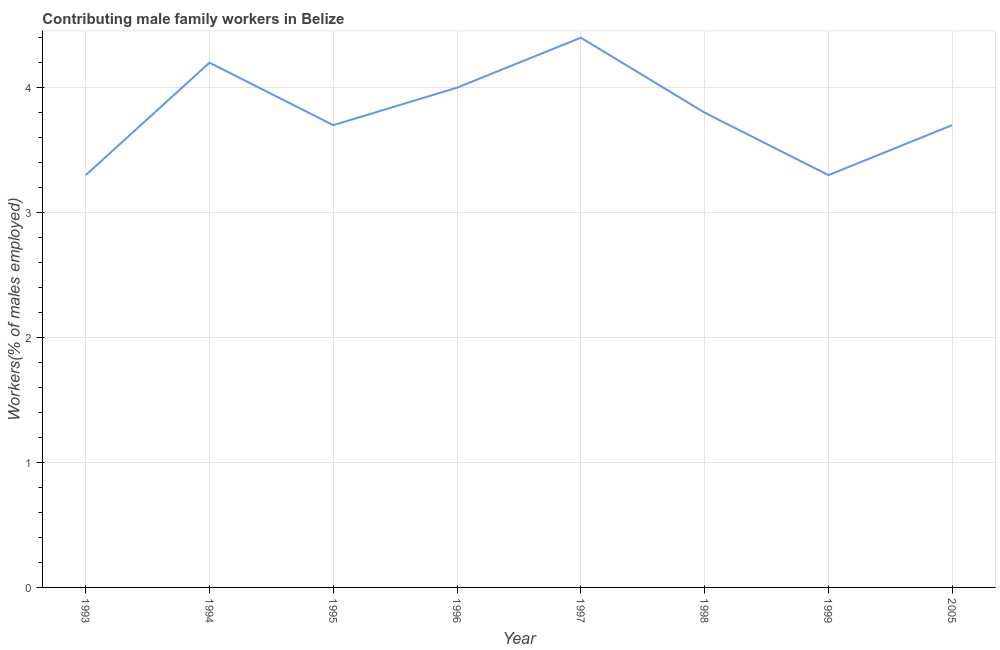What is the contributing male family workers in 2005?
Provide a short and direct response. 3.7. Across all years, what is the maximum contributing male family workers?
Offer a very short reply. 4.4. Across all years, what is the minimum contributing male family workers?
Provide a succinct answer. 3.3. In which year was the contributing male family workers maximum?
Make the answer very short. 1997. In which year was the contributing male family workers minimum?
Give a very brief answer. 1993. What is the sum of the contributing male family workers?
Provide a short and direct response. 30.4. What is the difference between the contributing male family workers in 1997 and 2005?
Offer a terse response. 0.7. What is the average contributing male family workers per year?
Your answer should be compact. 3.8. What is the median contributing male family workers?
Your answer should be very brief. 3.75. Do a majority of the years between 1996 and 1997 (inclusive) have contributing male family workers greater than 2.4 %?
Provide a succinct answer. Yes. What is the difference between the highest and the second highest contributing male family workers?
Give a very brief answer. 0.2. Is the sum of the contributing male family workers in 1993 and 2005 greater than the maximum contributing male family workers across all years?
Offer a very short reply. Yes. What is the difference between the highest and the lowest contributing male family workers?
Provide a succinct answer. 1.1. How many lines are there?
Keep it short and to the point. 1. How many years are there in the graph?
Your answer should be very brief. 8. Are the values on the major ticks of Y-axis written in scientific E-notation?
Provide a succinct answer. No. Does the graph contain grids?
Make the answer very short. Yes. What is the title of the graph?
Give a very brief answer. Contributing male family workers in Belize. What is the label or title of the Y-axis?
Your answer should be compact. Workers(% of males employed). What is the Workers(% of males employed) in 1993?
Ensure brevity in your answer.  3.3. What is the Workers(% of males employed) of 1994?
Offer a very short reply. 4.2. What is the Workers(% of males employed) of 1995?
Keep it short and to the point. 3.7. What is the Workers(% of males employed) of 1997?
Your answer should be very brief. 4.4. What is the Workers(% of males employed) in 1998?
Offer a very short reply. 3.8. What is the Workers(% of males employed) in 1999?
Provide a short and direct response. 3.3. What is the Workers(% of males employed) in 2005?
Provide a short and direct response. 3.7. What is the difference between the Workers(% of males employed) in 1993 and 1994?
Provide a short and direct response. -0.9. What is the difference between the Workers(% of males employed) in 1993 and 1995?
Provide a short and direct response. -0.4. What is the difference between the Workers(% of males employed) in 1993 and 1998?
Keep it short and to the point. -0.5. What is the difference between the Workers(% of males employed) in 1993 and 1999?
Provide a short and direct response. 0. What is the difference between the Workers(% of males employed) in 1994 and 1996?
Your response must be concise. 0.2. What is the difference between the Workers(% of males employed) in 1994 and 2005?
Your answer should be compact. 0.5. What is the difference between the Workers(% of males employed) in 1995 and 1998?
Your answer should be very brief. -0.1. What is the difference between the Workers(% of males employed) in 1995 and 2005?
Ensure brevity in your answer.  0. What is the difference between the Workers(% of males employed) in 1996 and 1997?
Give a very brief answer. -0.4. What is the difference between the Workers(% of males employed) in 1996 and 1998?
Make the answer very short. 0.2. What is the difference between the Workers(% of males employed) in 1996 and 1999?
Keep it short and to the point. 0.7. What is the difference between the Workers(% of males employed) in 1997 and 2005?
Make the answer very short. 0.7. What is the difference between the Workers(% of males employed) in 1998 and 1999?
Make the answer very short. 0.5. What is the difference between the Workers(% of males employed) in 1998 and 2005?
Make the answer very short. 0.1. What is the ratio of the Workers(% of males employed) in 1993 to that in 1994?
Your answer should be very brief. 0.79. What is the ratio of the Workers(% of males employed) in 1993 to that in 1995?
Provide a short and direct response. 0.89. What is the ratio of the Workers(% of males employed) in 1993 to that in 1996?
Ensure brevity in your answer.  0.82. What is the ratio of the Workers(% of males employed) in 1993 to that in 1998?
Your answer should be compact. 0.87. What is the ratio of the Workers(% of males employed) in 1993 to that in 1999?
Provide a succinct answer. 1. What is the ratio of the Workers(% of males employed) in 1993 to that in 2005?
Your answer should be very brief. 0.89. What is the ratio of the Workers(% of males employed) in 1994 to that in 1995?
Give a very brief answer. 1.14. What is the ratio of the Workers(% of males employed) in 1994 to that in 1997?
Your response must be concise. 0.95. What is the ratio of the Workers(% of males employed) in 1994 to that in 1998?
Your response must be concise. 1.1. What is the ratio of the Workers(% of males employed) in 1994 to that in 1999?
Make the answer very short. 1.27. What is the ratio of the Workers(% of males employed) in 1994 to that in 2005?
Your answer should be very brief. 1.14. What is the ratio of the Workers(% of males employed) in 1995 to that in 1996?
Keep it short and to the point. 0.93. What is the ratio of the Workers(% of males employed) in 1995 to that in 1997?
Provide a short and direct response. 0.84. What is the ratio of the Workers(% of males employed) in 1995 to that in 1998?
Provide a succinct answer. 0.97. What is the ratio of the Workers(% of males employed) in 1995 to that in 1999?
Ensure brevity in your answer.  1.12. What is the ratio of the Workers(% of males employed) in 1995 to that in 2005?
Ensure brevity in your answer.  1. What is the ratio of the Workers(% of males employed) in 1996 to that in 1997?
Offer a very short reply. 0.91. What is the ratio of the Workers(% of males employed) in 1996 to that in 1998?
Provide a succinct answer. 1.05. What is the ratio of the Workers(% of males employed) in 1996 to that in 1999?
Provide a succinct answer. 1.21. What is the ratio of the Workers(% of males employed) in 1996 to that in 2005?
Your answer should be very brief. 1.08. What is the ratio of the Workers(% of males employed) in 1997 to that in 1998?
Give a very brief answer. 1.16. What is the ratio of the Workers(% of males employed) in 1997 to that in 1999?
Ensure brevity in your answer.  1.33. What is the ratio of the Workers(% of males employed) in 1997 to that in 2005?
Keep it short and to the point. 1.19. What is the ratio of the Workers(% of males employed) in 1998 to that in 1999?
Offer a very short reply. 1.15. What is the ratio of the Workers(% of males employed) in 1999 to that in 2005?
Ensure brevity in your answer.  0.89. 